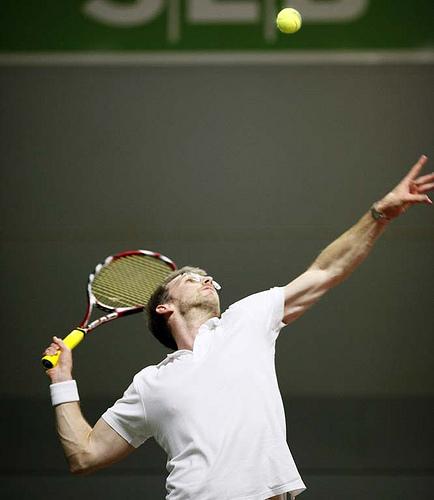Is the tennis ball visible in the photo?
Answer briefly. Yes. Is this man serving?
Answer briefly. Yes. Is the man wearing a wristband?
Give a very brief answer. Yes. 